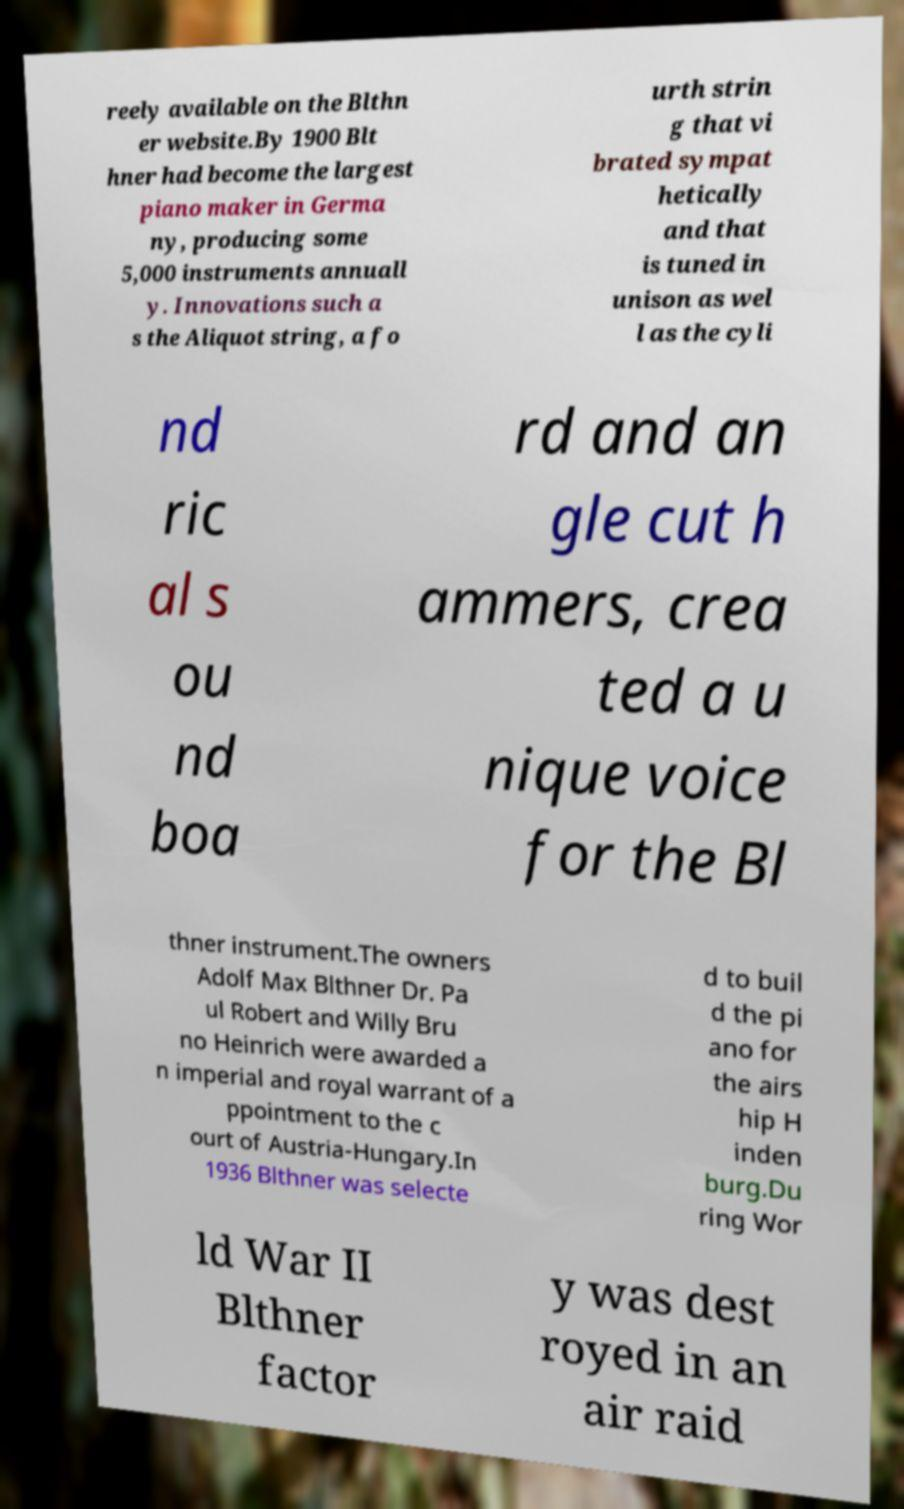I need the written content from this picture converted into text. Can you do that? reely available on the Blthn er website.By 1900 Blt hner had become the largest piano maker in Germa ny, producing some 5,000 instruments annuall y. Innovations such a s the Aliquot string, a fo urth strin g that vi brated sympat hetically and that is tuned in unison as wel l as the cyli nd ric al s ou nd boa rd and an gle cut h ammers, crea ted a u nique voice for the Bl thner instrument.The owners Adolf Max Blthner Dr. Pa ul Robert and Willy Bru no Heinrich were awarded a n imperial and royal warrant of a ppointment to the c ourt of Austria-Hungary.In 1936 Blthner was selecte d to buil d the pi ano for the airs hip H inden burg.Du ring Wor ld War II Blthner factor y was dest royed in an air raid 